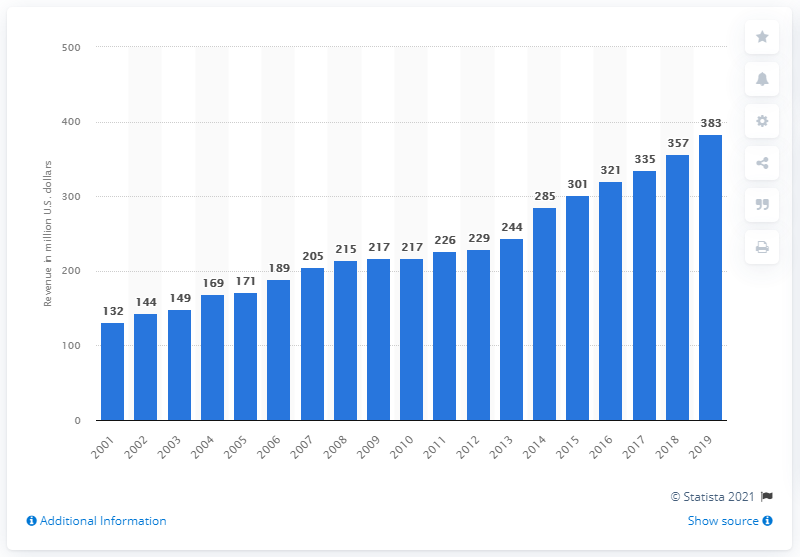Specify some key components in this picture. The revenue of the Las Vegas Raiders in 2019 was $383 million. In the year 2001, the Las Vegas Raiders became a franchise of the National Football League. 